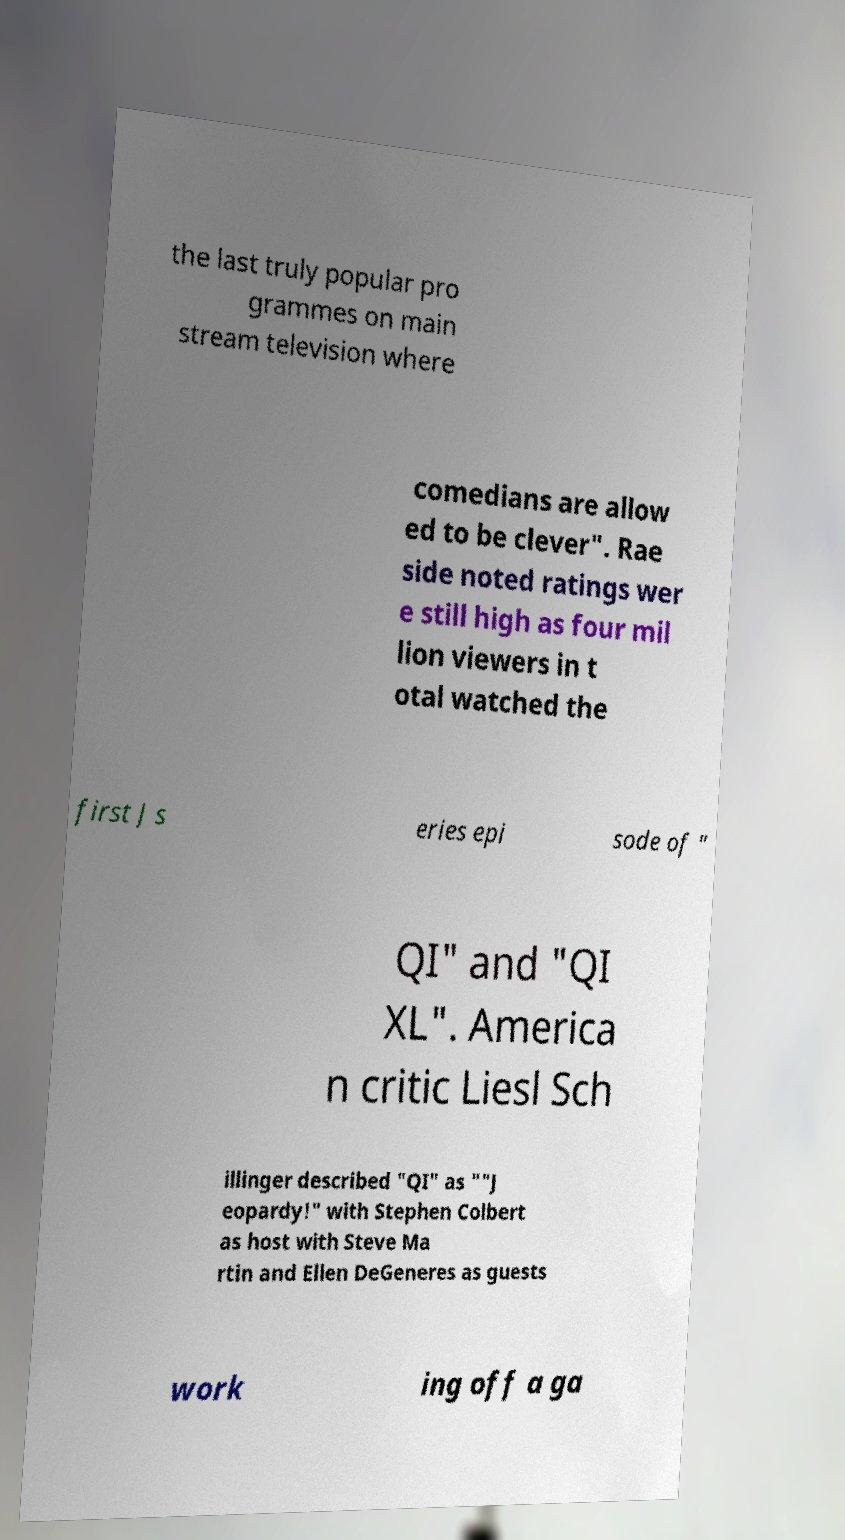Could you extract and type out the text from this image? the last truly popular pro grammes on main stream television where comedians are allow ed to be clever". Rae side noted ratings wer e still high as four mil lion viewers in t otal watched the first J s eries epi sode of " QI" and "QI XL". America n critic Liesl Sch illinger described "QI" as ""J eopardy!" with Stephen Colbert as host with Steve Ma rtin and Ellen DeGeneres as guests work ing off a ga 